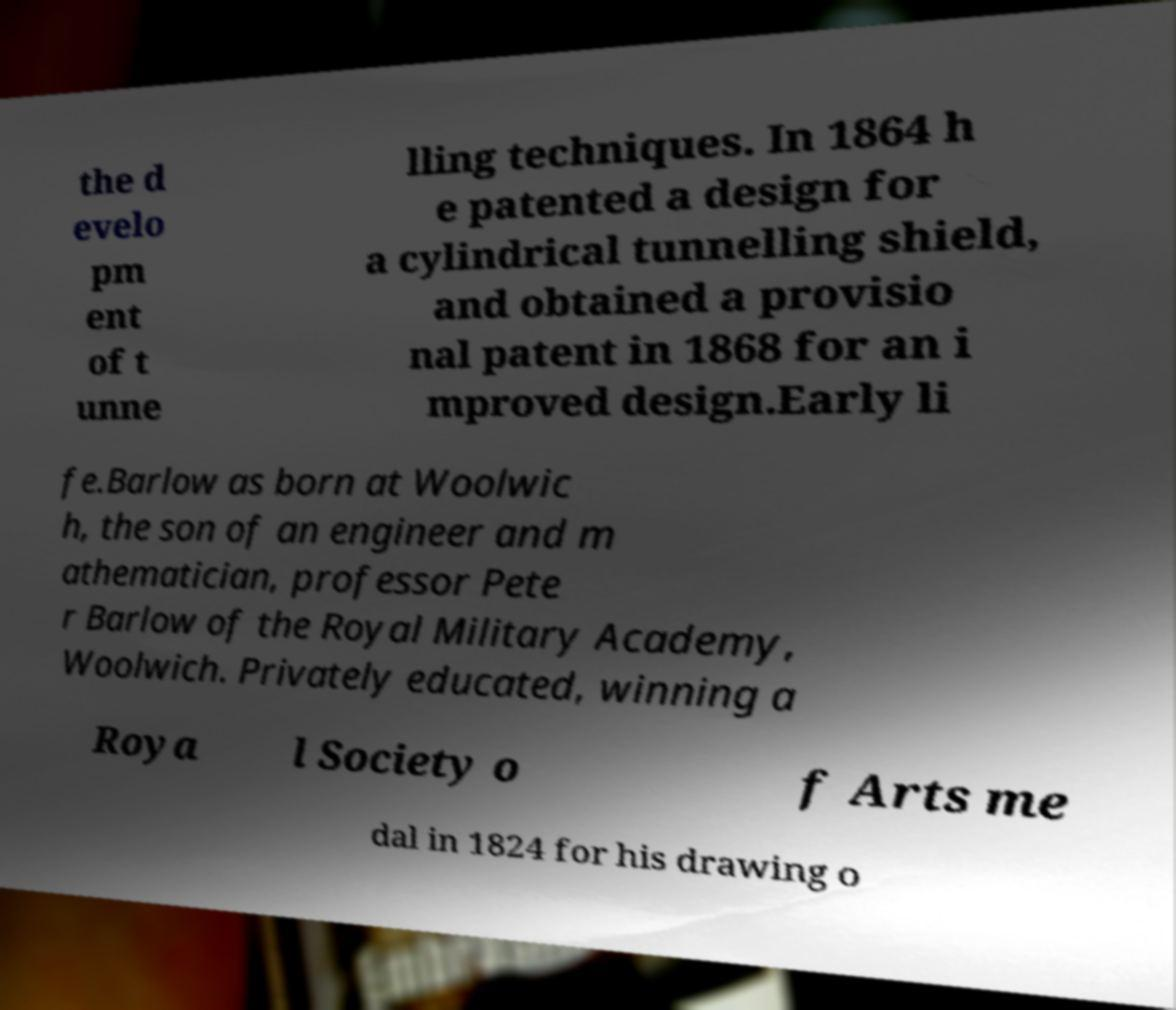I need the written content from this picture converted into text. Can you do that? the d evelo pm ent of t unne lling techniques. In 1864 h e patented a design for a cylindrical tunnelling shield, and obtained a provisio nal patent in 1868 for an i mproved design.Early li fe.Barlow as born at Woolwic h, the son of an engineer and m athematician, professor Pete r Barlow of the Royal Military Academy, Woolwich. Privately educated, winning a Roya l Society o f Arts me dal in 1824 for his drawing o 